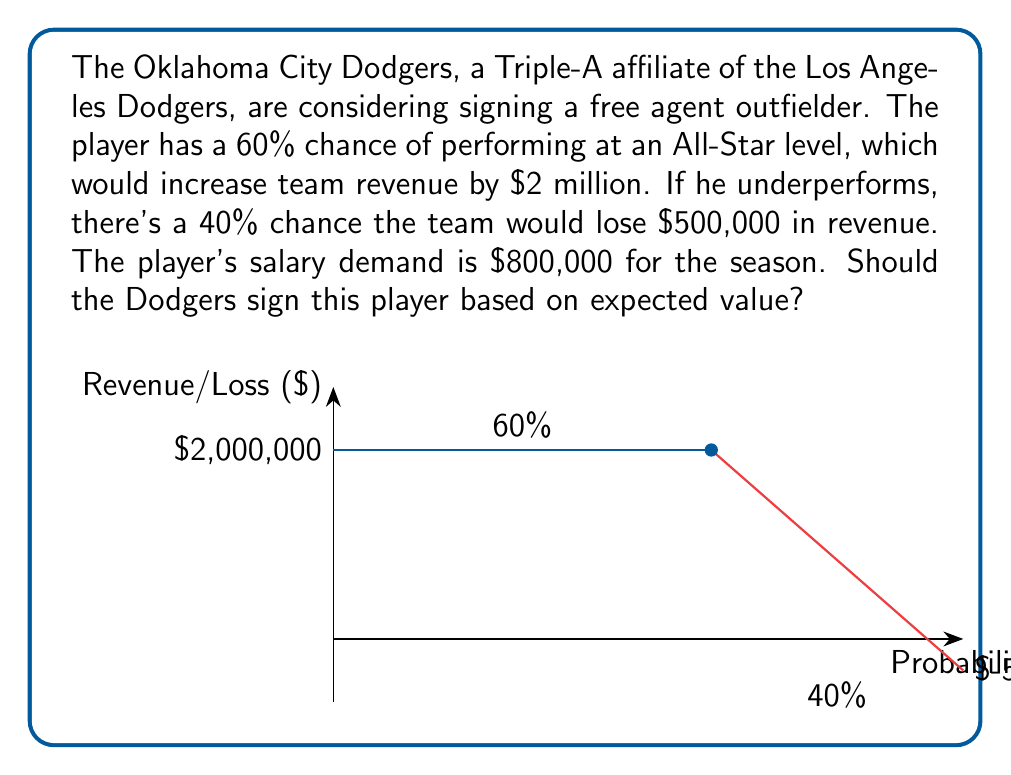Provide a solution to this math problem. To determine if the Dodgers should sign the player, we need to calculate the expected value of the decision and compare it to the cost.

Step 1: Calculate the expected revenue
- Probability of All-Star performance: 60% = 0.6
- Revenue if All-Star: $2,000,000
- Probability of underperformance: 40% = 0.4
- Loss if underperforms: $500,000

Expected Revenue = $$(0.6 \times \$2,000,000) + (0.4 \times (-\$500,000))$$
                 = $$\$1,200,000 - \$200,000$$
                 = $$\$1,000,000$$

Step 2: Calculate the net expected value
Net Expected Value = Expected Revenue - Player's Salary
                   = $$\$1,000,000 - \$800,000$$
                   = $$\$200,000$$

Step 3: Make the decision
Since the net expected value is positive ($200,000), it would be beneficial for the Dodgers to sign the player.

The expected value calculation shows that, on average, the team would gain $200,000 by signing this player, even after paying his salary.
Answer: Yes, sign the player (Net EV = $200,000) 